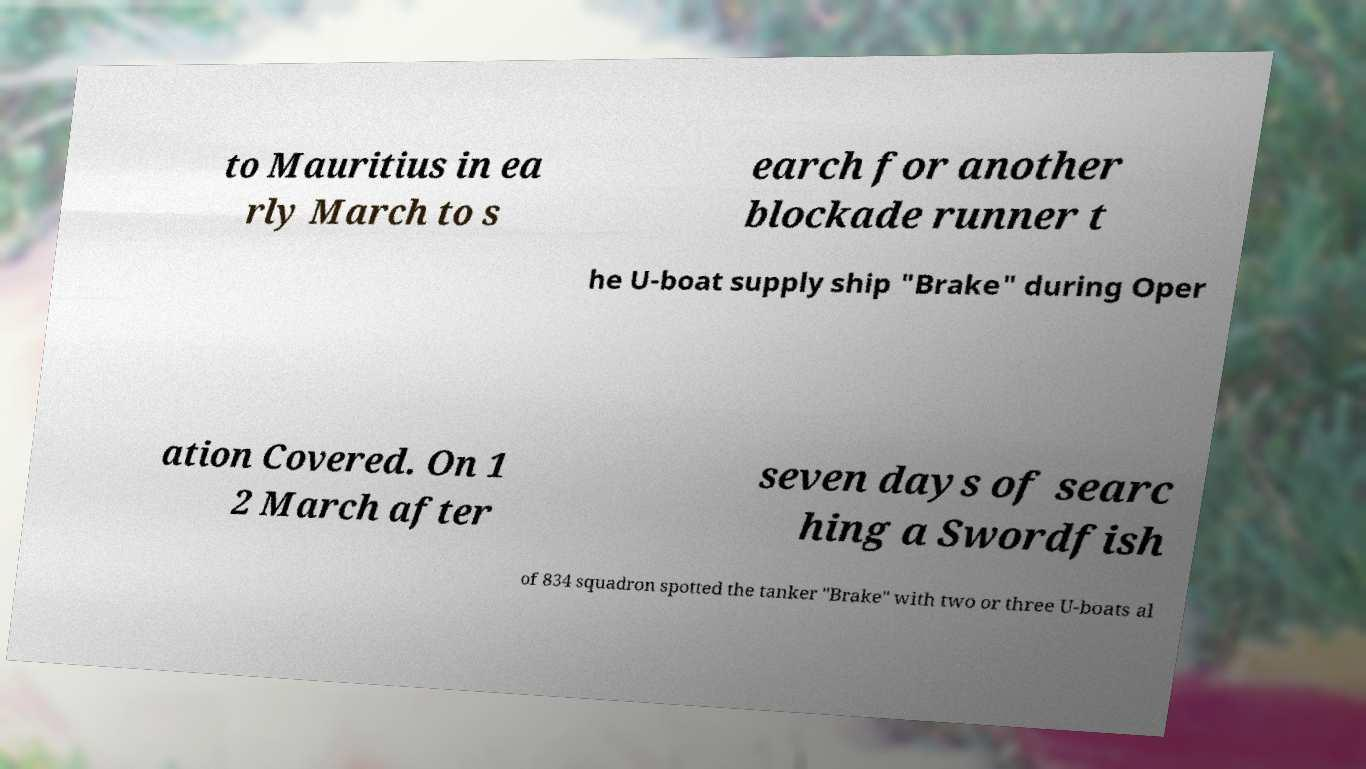I need the written content from this picture converted into text. Can you do that? to Mauritius in ea rly March to s earch for another blockade runner t he U-boat supply ship "Brake" during Oper ation Covered. On 1 2 March after seven days of searc hing a Swordfish of 834 squadron spotted the tanker "Brake" with two or three U-boats al 